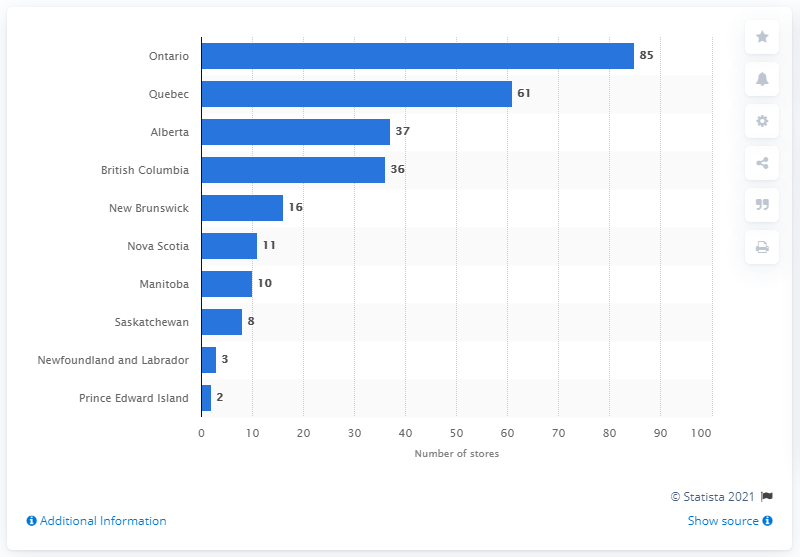Highlight a few significant elements in this photo. In 2020, there were 85 outdoor power equipment stores operating in Ontario. In 2020, Ontario had 85 outdoor power equipment stores. 